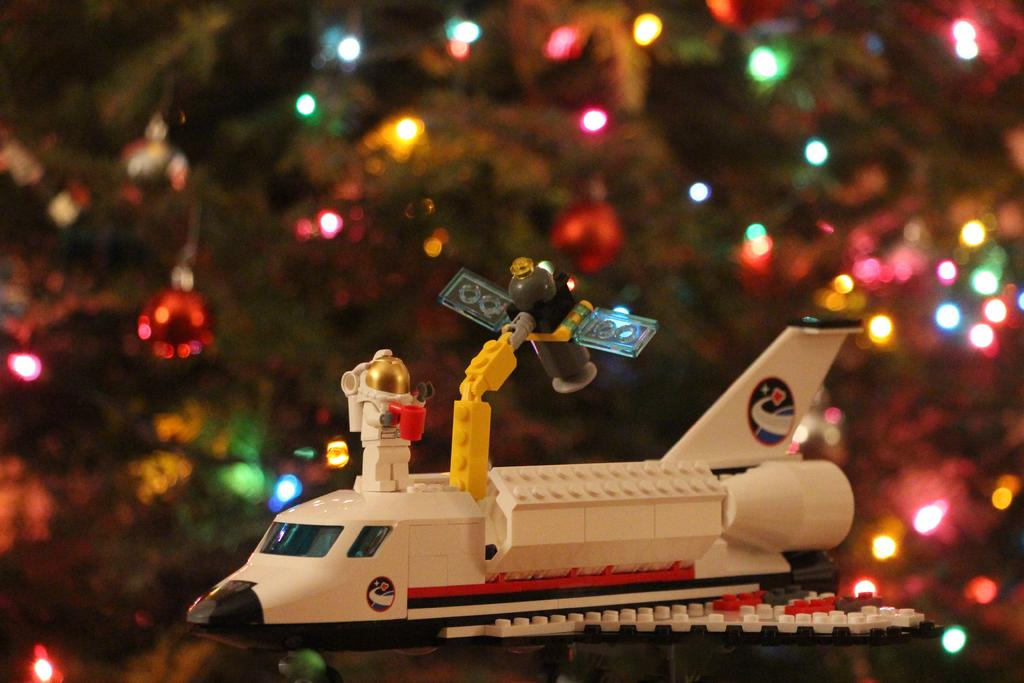What is the main subject in the center of the image? There is a toy aeroplane in the center of the image. What can be seen in the background of the image? There is an xmas tree in the background of the image. How much rice is on the toy aeroplane in the image? There is no rice present on the toy aeroplane in the image. What type of stem can be seen growing from the xmas tree in the image? There is no stem visible in the image, as the focus is on the xmas tree itself and not its individual components. 